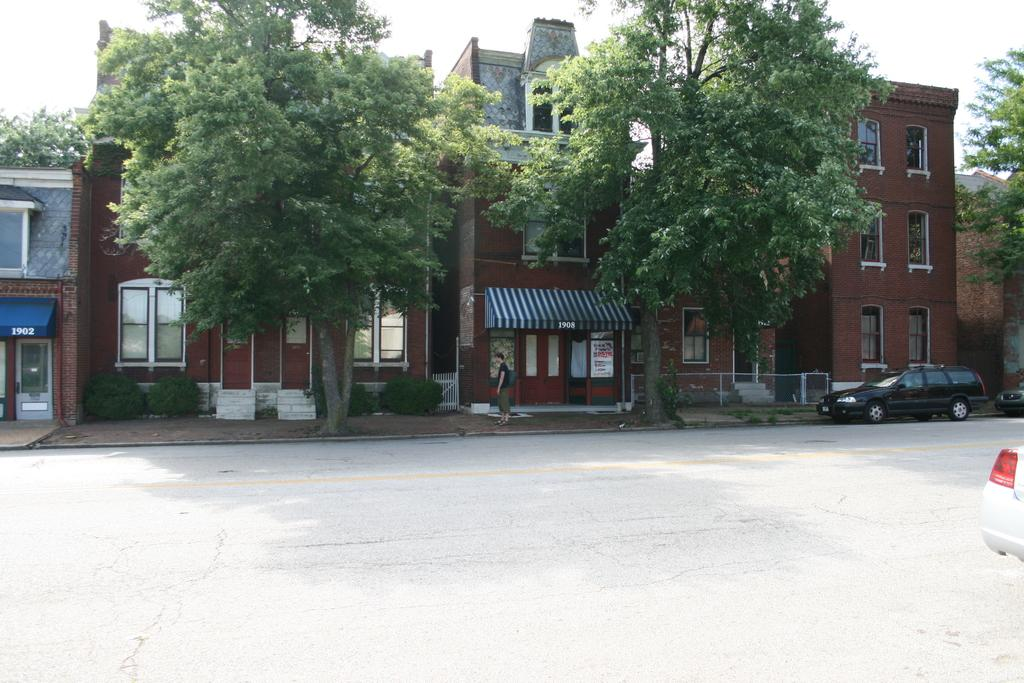What can be seen on the road in the image? There are vehicles on the road in the image. What is the person standing doing? The facts do not specify what the person is doing, but they are standing. What type of vegetation is present in the image? There are trees in the image. What type of structures can be seen in the image? There are buildings in the image. What type of barrier is present in the image? There is a fence in the image. What is visible in the background of the image? The sky is visible in the background of the image. Where is the mailbox located in the image? There is no mailbox present in the image. What type of feast is being prepared in the image? There is no feast being prepared in the image. 